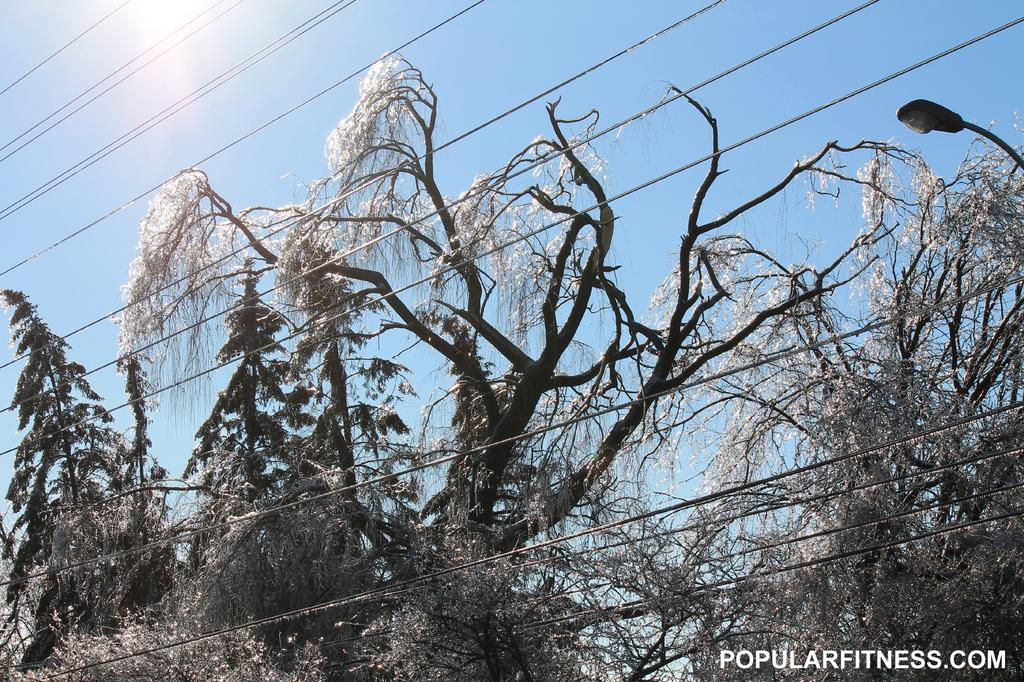What type of vegetation can be seen in the image? There are trees in the image. What type of lighting is present in the image? There is a pole light in the image. What else can be seen in the image besides trees and the pole light? There are wires in the image. What is the color of the sky in the image? The sky is blue in the image. What can be inferred about the weather or time of day from the image? Sunlight is visible in the image, suggesting it is daytime. What is present at the bottom right corner of the image? There is text at the bottom right corner of the image. What type of knee injury is the queen suffering from in the image? There is no queen or knee injury present in the image; it features trees, a pole light, wires, a blue sky, sunlight, and text at the bottom right corner. What type of stove is visible in the image? There is no stove present in the image. 